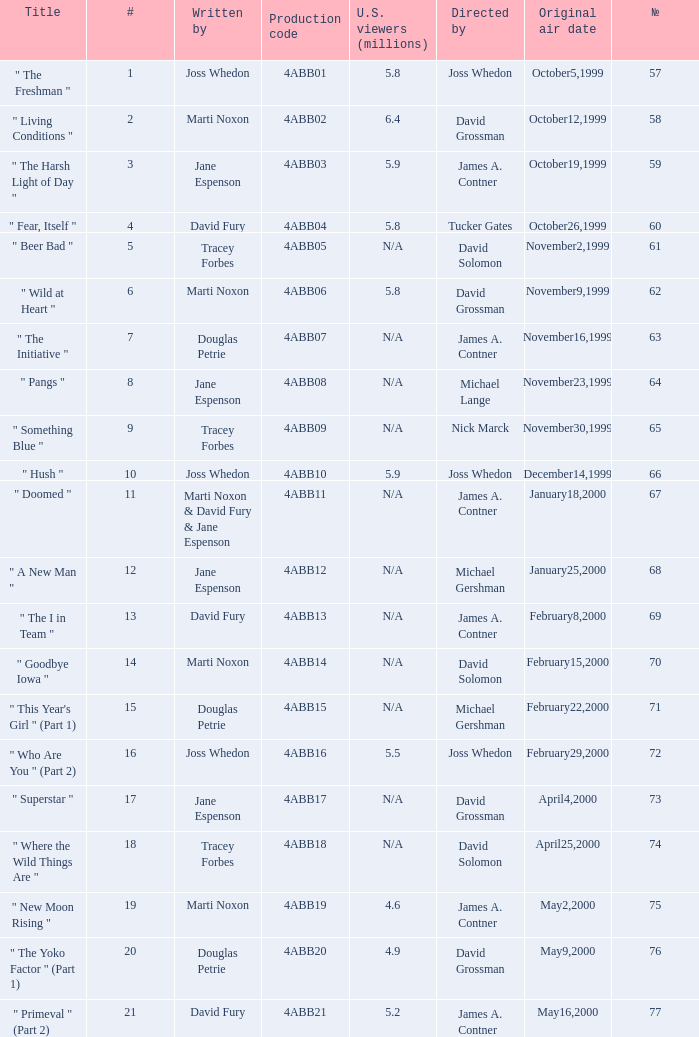What is the title of episode No. 65? " Something Blue ". 